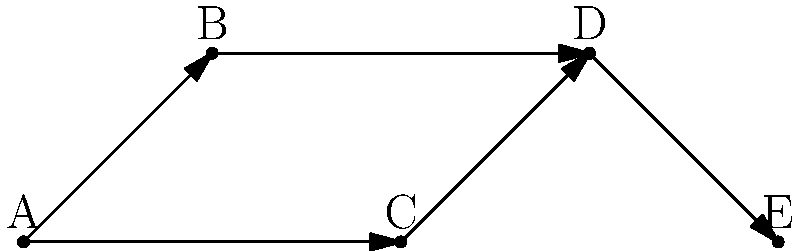In the legal precedent citation network shown above, where each node represents a case and each directed edge represents a citation, what is the shortest path from case A to case E? List the cases in order. To find the shortest path from case A to case E, we need to analyze the network step by step:

1. Start at node A.
2. From A, we can go to either B or C.
3. If we go to B:
   - The path would be A → B → D → E (3 steps)
4. If we go to C:
   - The path would be A → C → D → E (3 steps)
5. Both paths have the same length (3 steps), so either is a valid shortest path.

For this answer, we'll choose the path through B, as it appears first alphabetically.

Therefore, the shortest path from A to E is: A → B → D → E.
Answer: A → B → D → E 